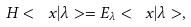Convert formula to latex. <formula><loc_0><loc_0><loc_500><loc_500>H < \ x | \lambda > = E _ { \lambda } < \ x | \lambda > ,</formula> 